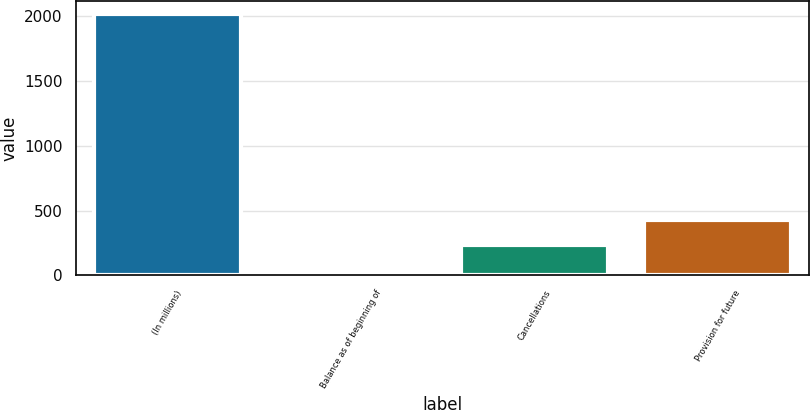<chart> <loc_0><loc_0><loc_500><loc_500><bar_chart><fcel>(In millions)<fcel>Balance as of beginning of<fcel>Cancellations<fcel>Provision for future<nl><fcel>2014<fcel>32.7<fcel>230.83<fcel>428.96<nl></chart> 